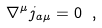<formula> <loc_0><loc_0><loc_500><loc_500>\nabla ^ { \mu } j _ { a \mu } = 0 \ ,</formula> 